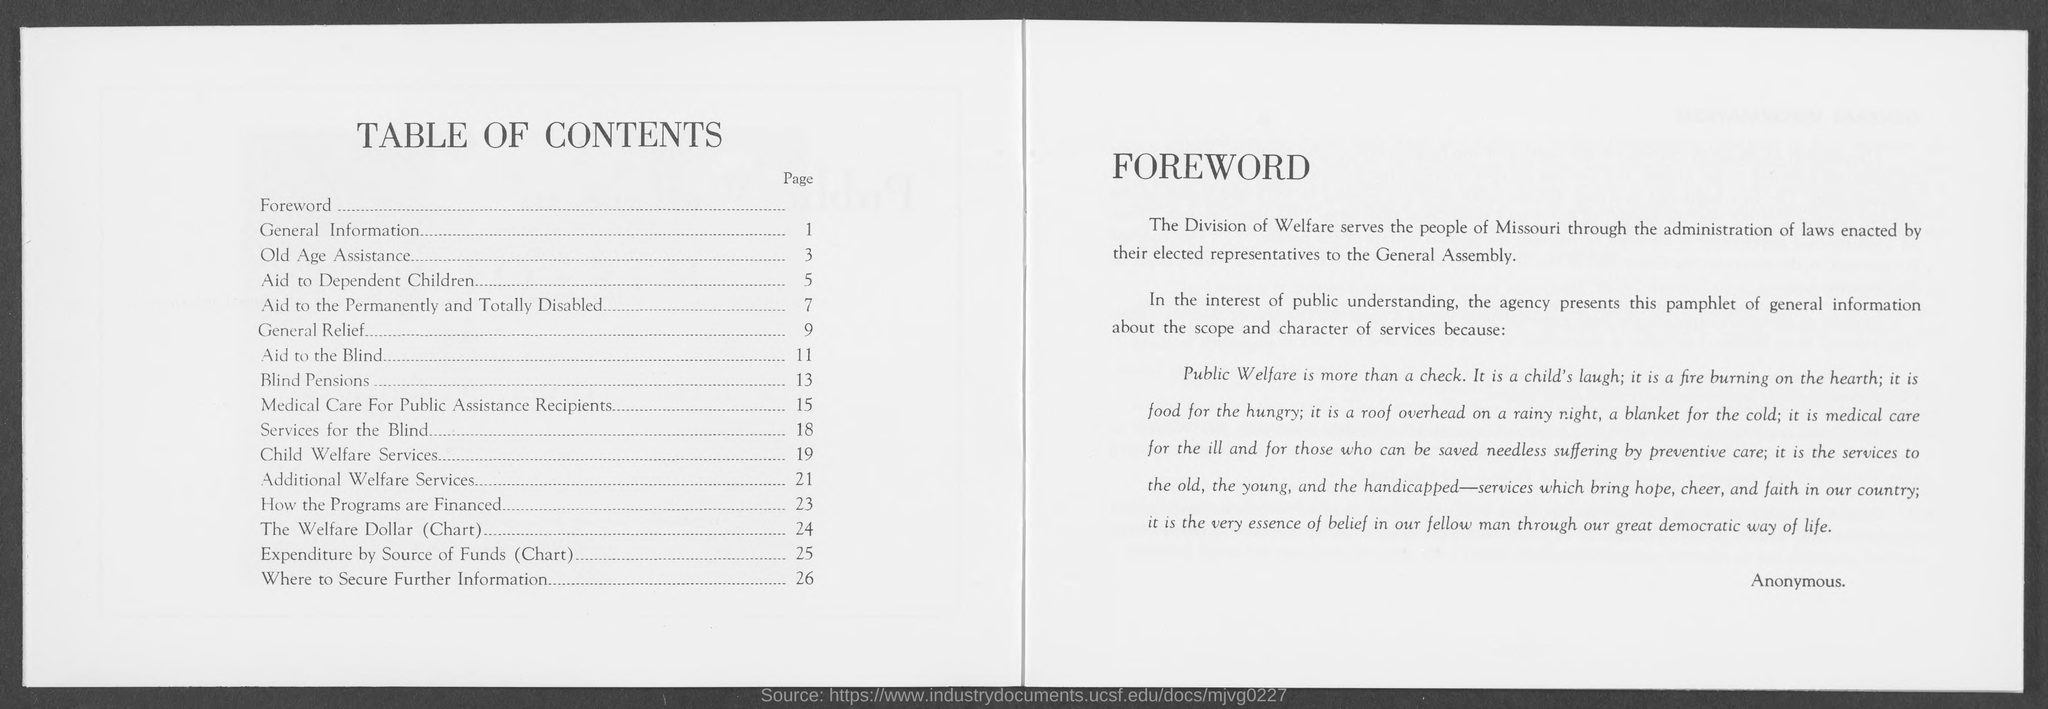What is the title of the left page ?
Your answer should be very brief. Table of Contents. What is the page number for general information?
Offer a terse response. 1. What is the page number for old age assistance ?
Your response must be concise. 3. What is the page number for aid to dependent children?
Offer a terse response. 5. What is the page number for aid to the permanently and totally disabled ?
Provide a short and direct response. 7. What is the page number for general relief ?
Give a very brief answer. 9. What is the page number for aid to the blind ?
Your response must be concise. 11. What is the page number for blind pensions?
Your response must be concise. 13. What is the page number for medical care for public assistance recipients ?
Your answer should be compact. 15. What is the page number for services for the blind?
Your answer should be very brief. 18. 